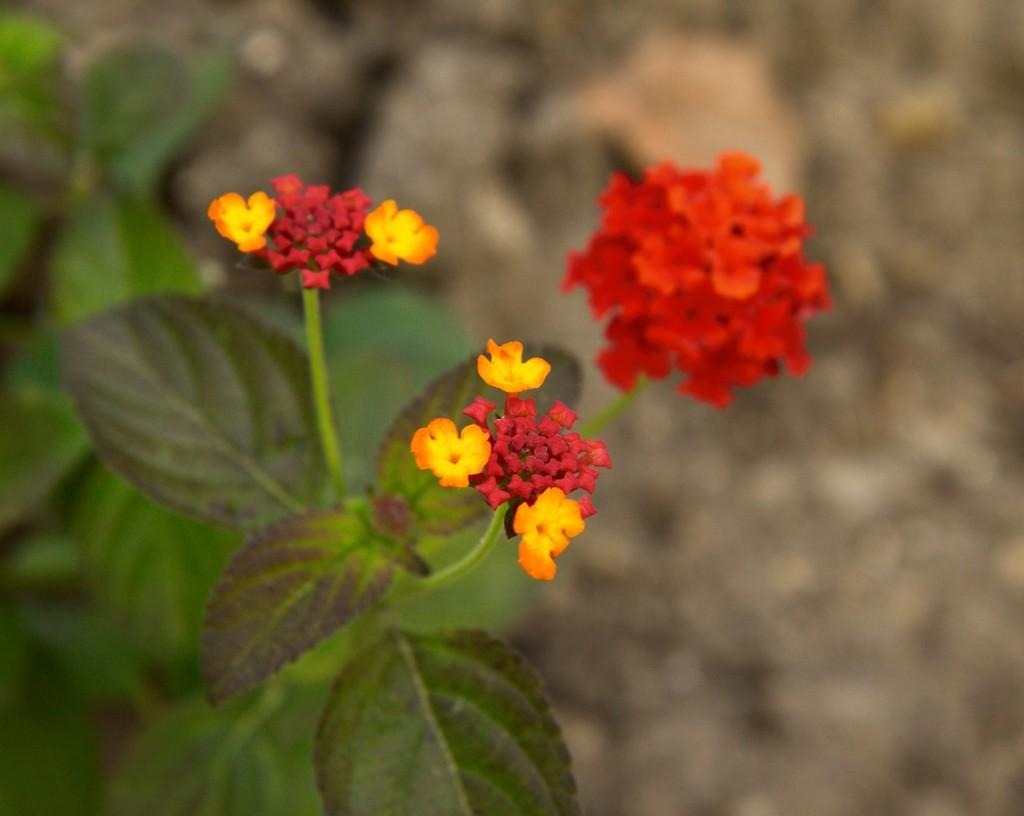What type of flowers can be seen in the image? There are red and yellow color flowers in the image. What else is present in the image besides flowers? There are plants in the image. Can you describe the background of the image? The background of the image is blurred. What type of payment is being made in the image? There is no payment being made in the image; it features flowers and plants. Can you see a horn in the image? There is no horn present in the image. 